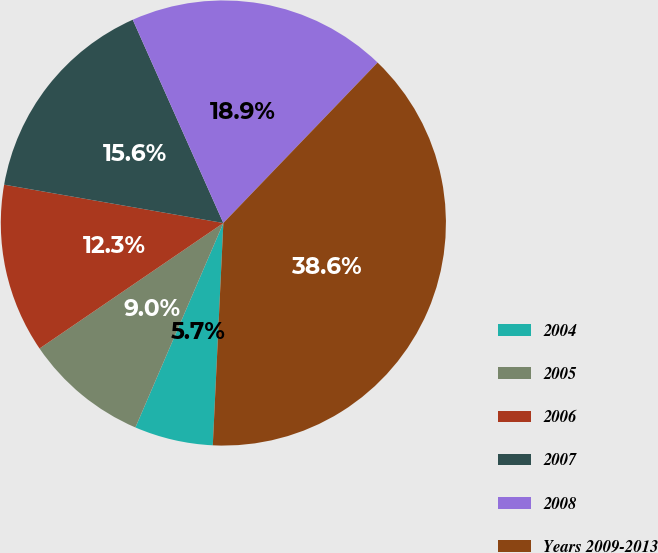<chart> <loc_0><loc_0><loc_500><loc_500><pie_chart><fcel>2004<fcel>2005<fcel>2006<fcel>2007<fcel>2008<fcel>Years 2009-2013<nl><fcel>5.71%<fcel>9.0%<fcel>12.29%<fcel>15.57%<fcel>18.86%<fcel>38.57%<nl></chart> 